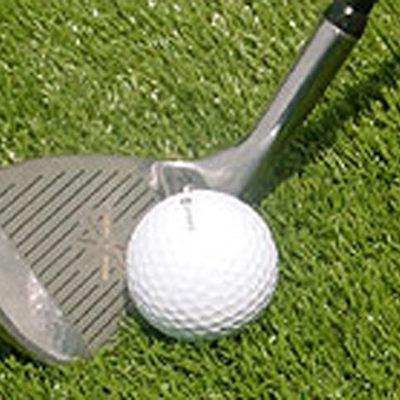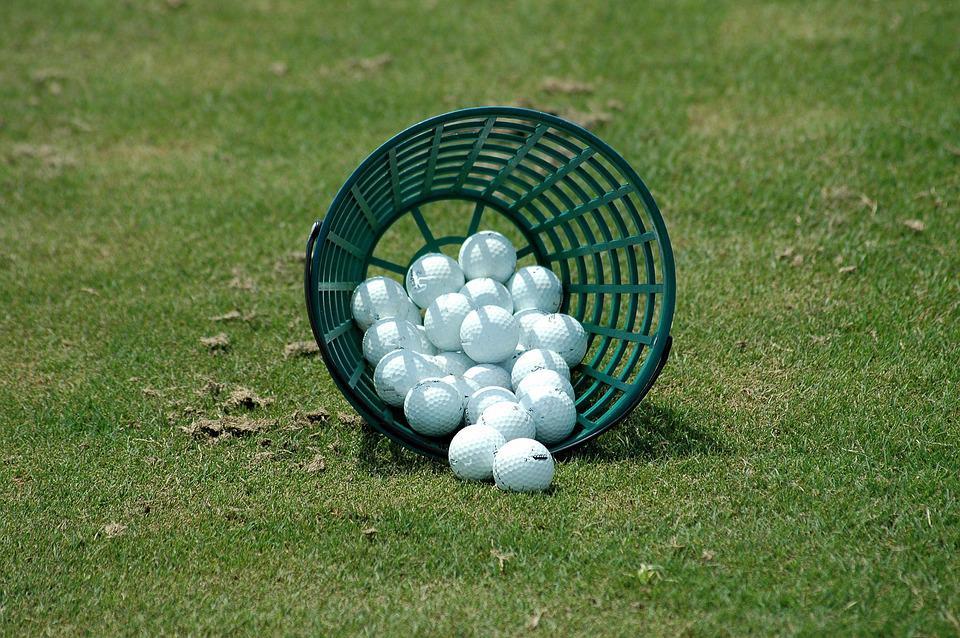The first image is the image on the left, the second image is the image on the right. Analyze the images presented: Is the assertion "A golf club is next to at least one golf ball in one image." valid? Answer yes or no. Yes. The first image is the image on the left, the second image is the image on the right. Given the left and right images, does the statement "In one photo, a green bucket of golf balls is laying on its side in grass with no golf clubs visible" hold true? Answer yes or no. Yes. 